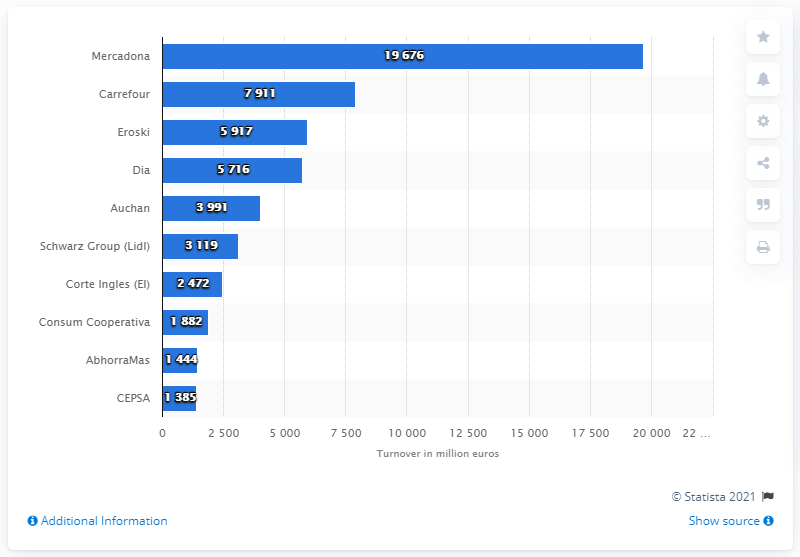Point out several critical features in this image. Mercadona's turnover in 2013 was 19,676. In 2013, Eroski was the largest grocery retailer in Spain. 